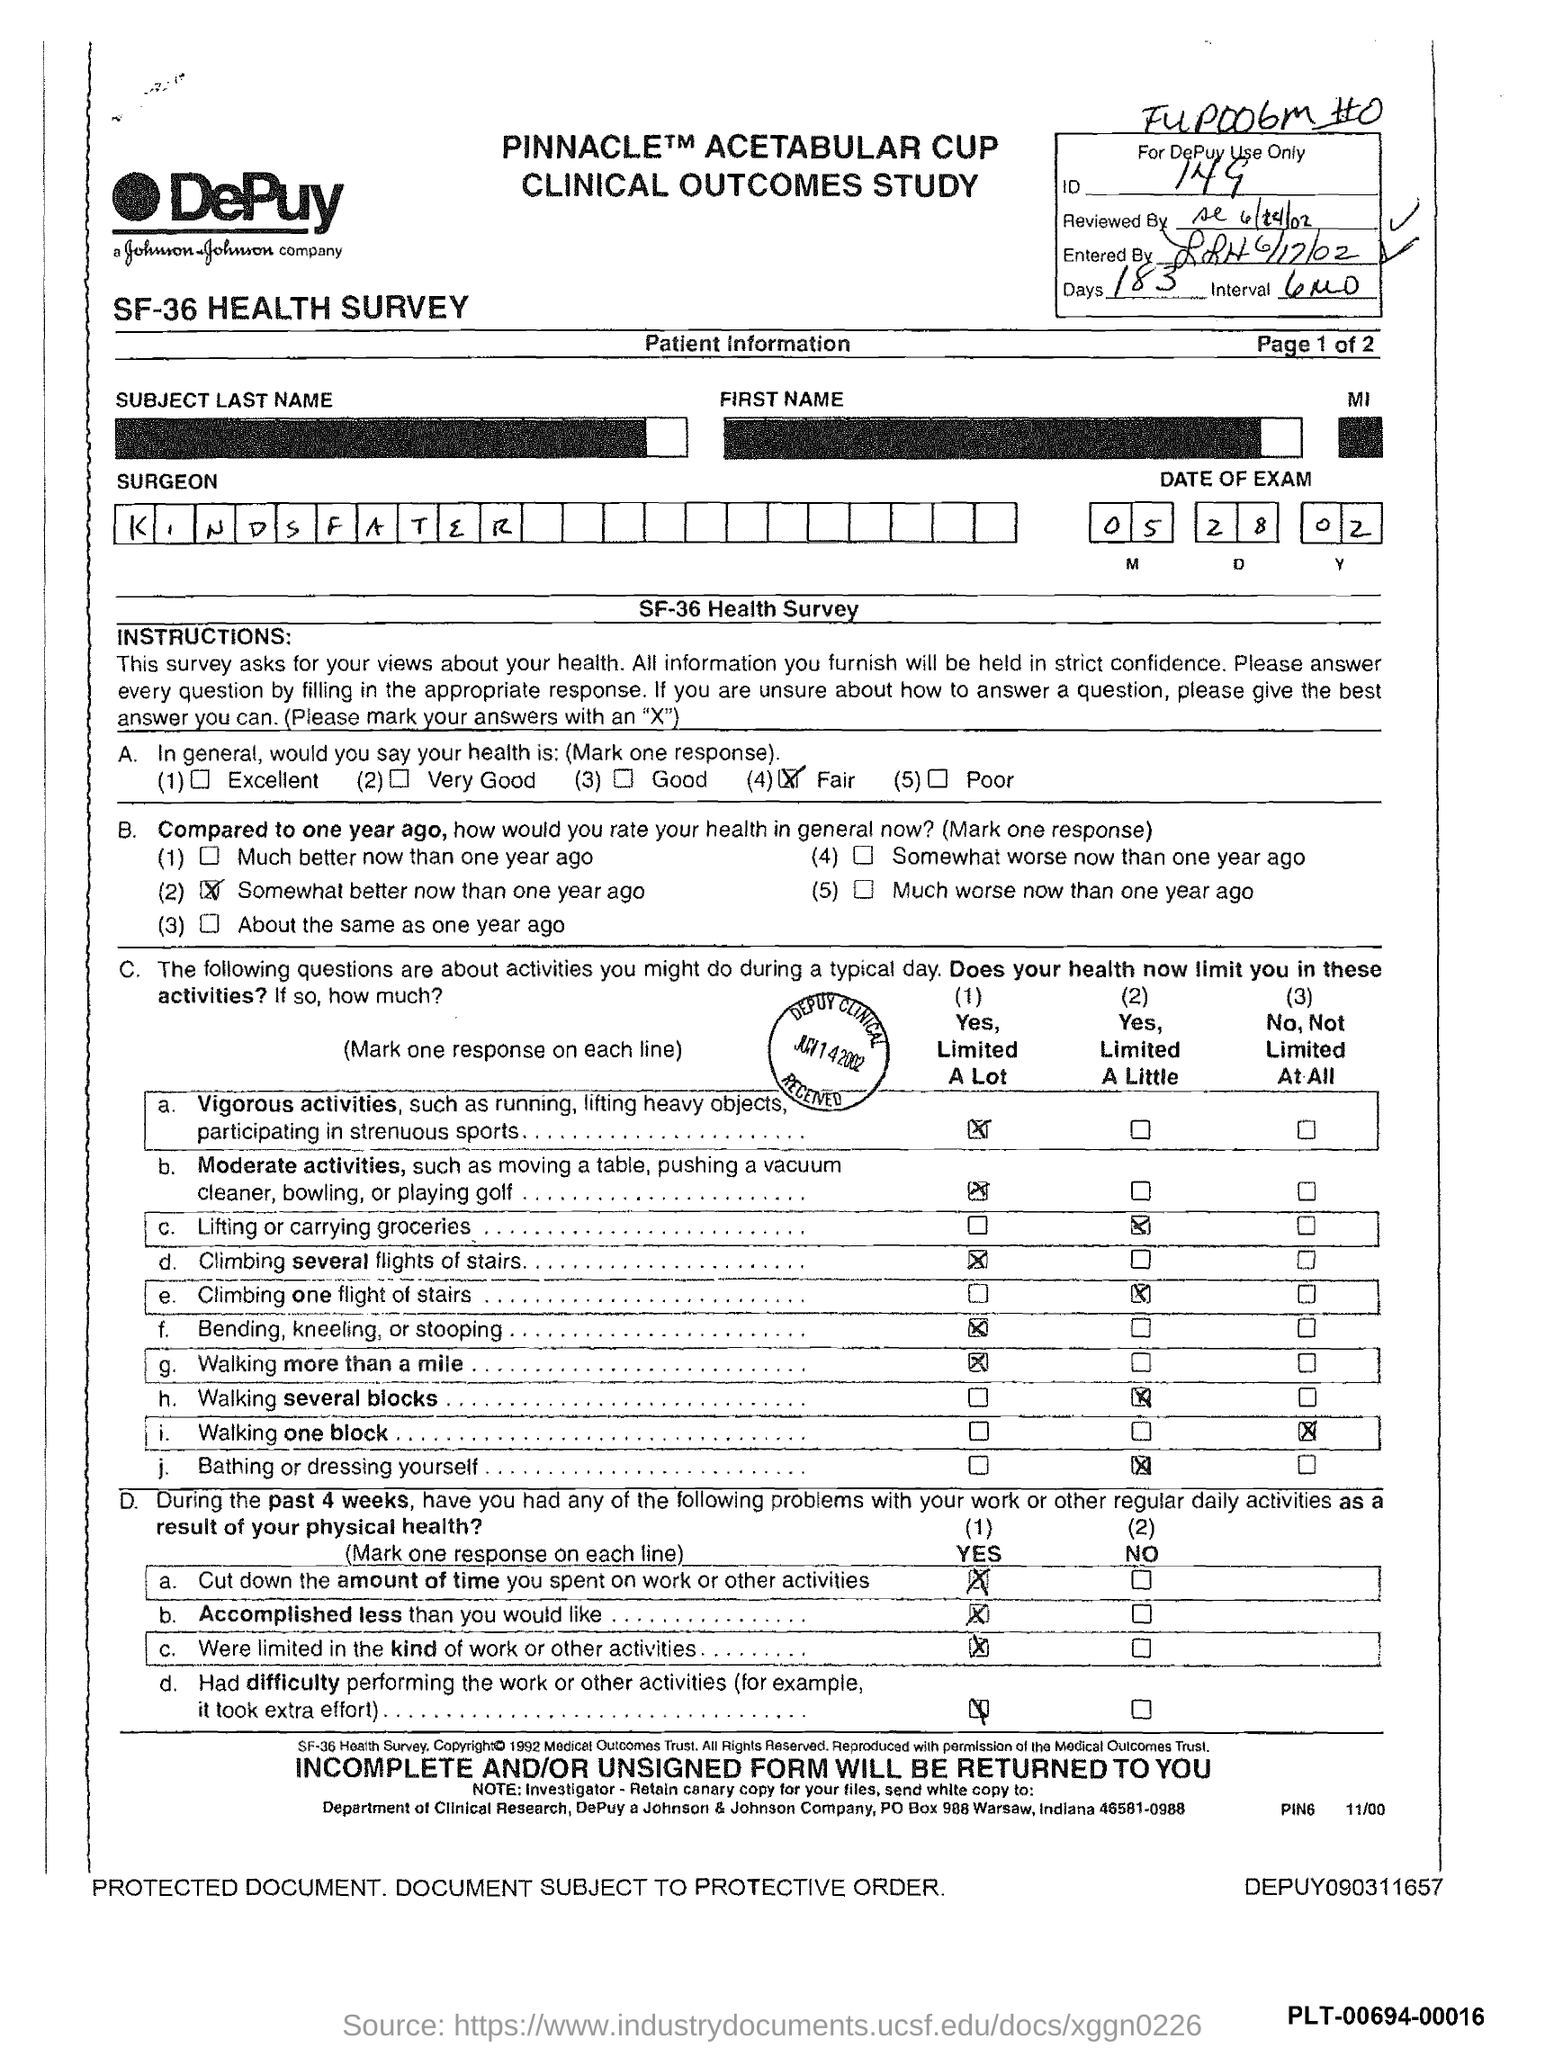Highlight a few significant elements in this photo. There are 183 days given in the form. The ID mentioned in the form is 149. The surgeon's name mentioned in the form is Kindsfater. The date of the exam specified in the form is May 28, 2002. 